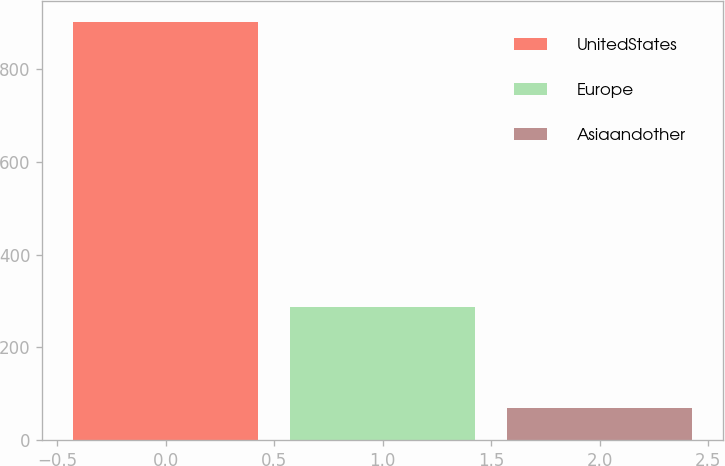Convert chart. <chart><loc_0><loc_0><loc_500><loc_500><bar_chart><fcel>UnitedStates<fcel>Europe<fcel>Asiaandother<nl><fcel>901<fcel>287<fcel>69<nl></chart> 